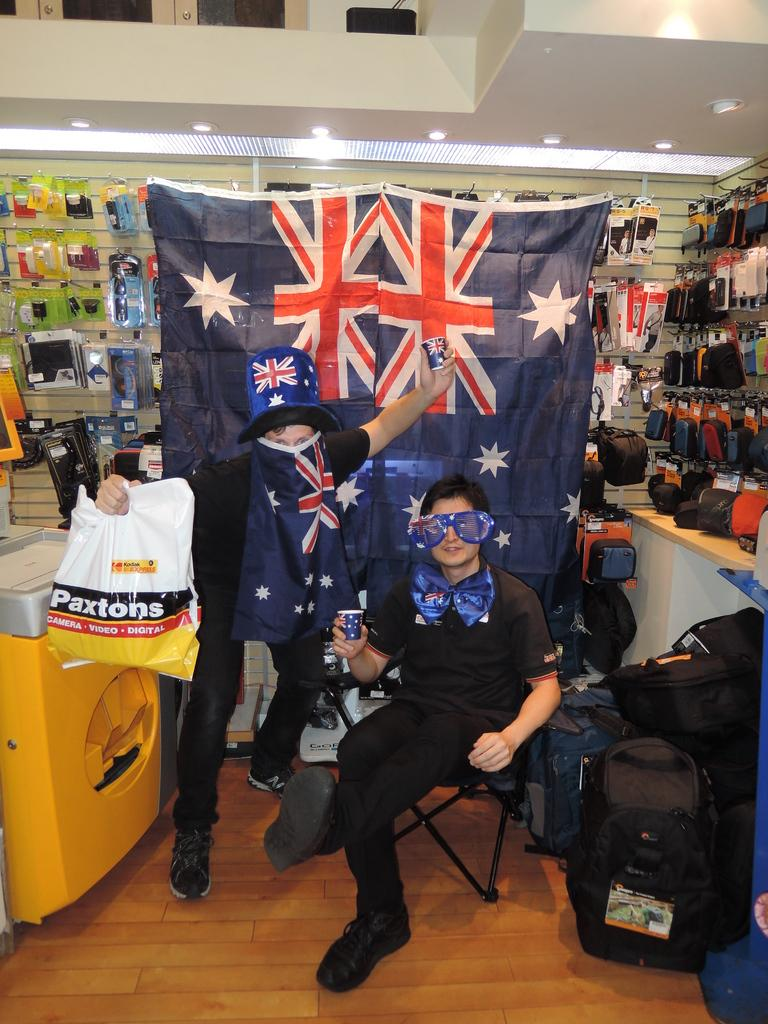<image>
Provide a brief description of the given image. People are in front of a flag and one is holding a bag from Paxtons. 